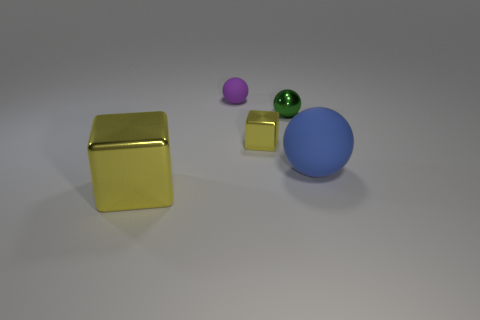Subtract all small spheres. How many spheres are left? 1 Add 4 yellow rubber blocks. How many objects exist? 9 Subtract all gray balls. Subtract all red blocks. How many balls are left? 3 Subtract all balls. How many objects are left? 2 Add 5 tiny yellow shiny things. How many tiny yellow shiny things are left? 6 Add 1 metal spheres. How many metal spheres exist? 2 Subtract 0 red cylinders. How many objects are left? 5 Subtract all tiny metallic things. Subtract all yellow shiny blocks. How many objects are left? 1 